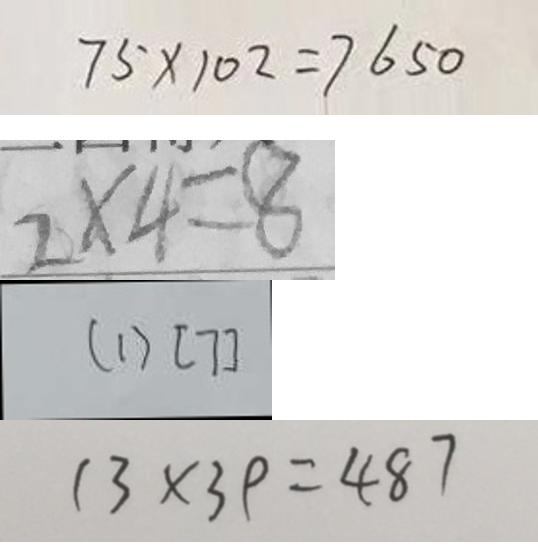<formula> <loc_0><loc_0><loc_500><loc_500>7 5 \times 1 0 2 = 7 6 5 0 
 2 \times 4 = 8 
 ( 1 ) [ 7 ] 
 1 3 \times 3 9 = 4 8 7</formula> 